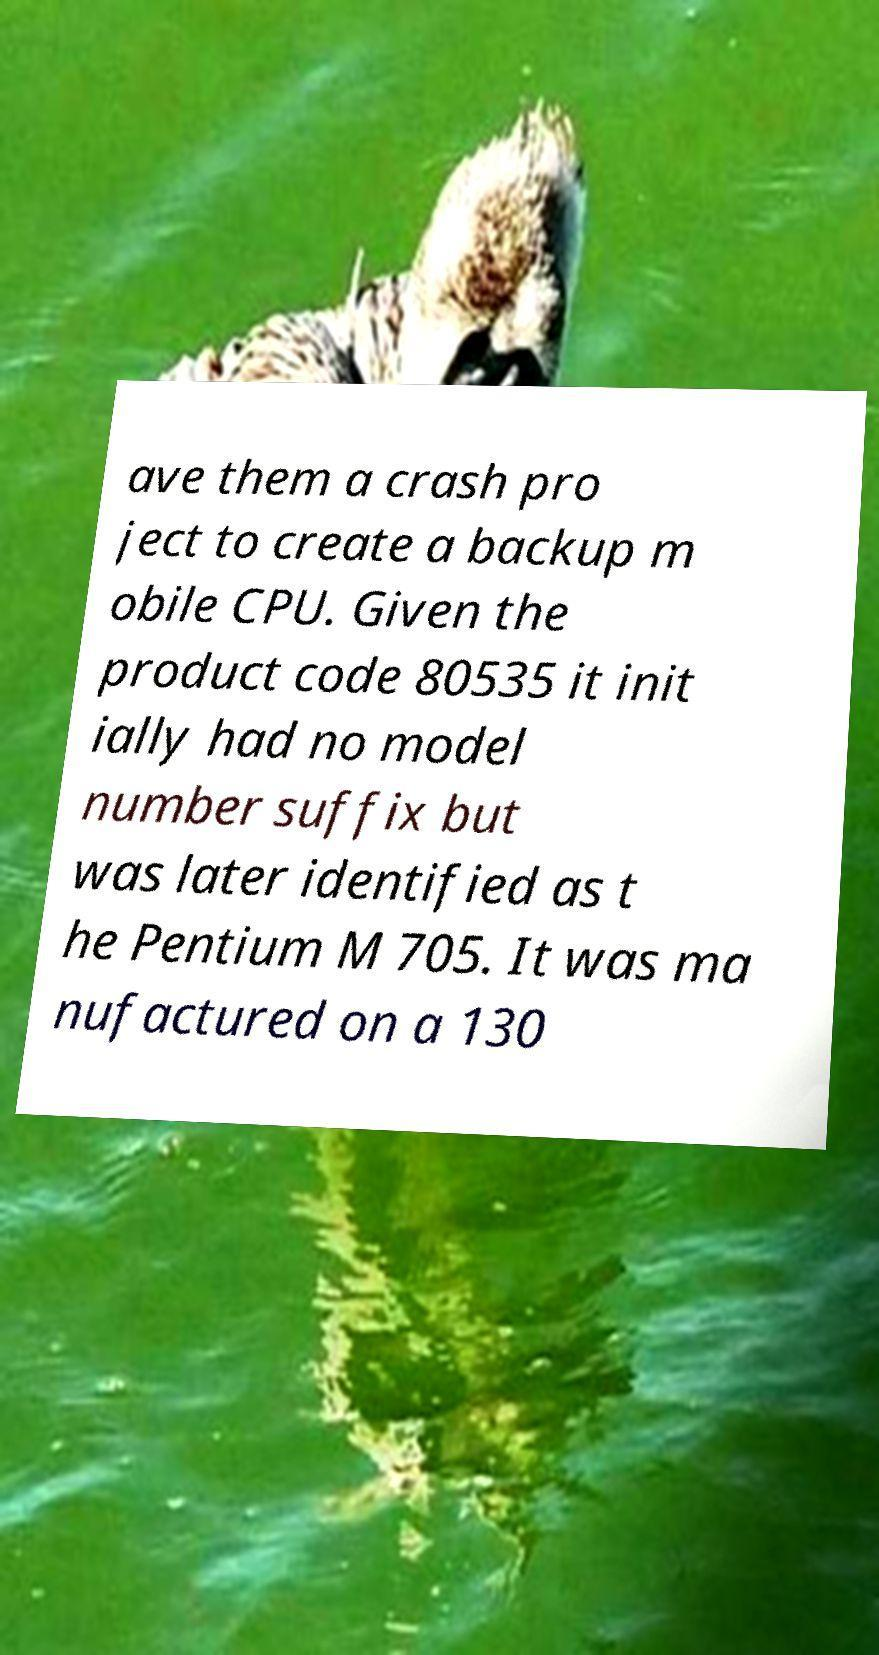Could you extract and type out the text from this image? ave them a crash pro ject to create a backup m obile CPU. Given the product code 80535 it init ially had no model number suffix but was later identified as t he Pentium M 705. It was ma nufactured on a 130 